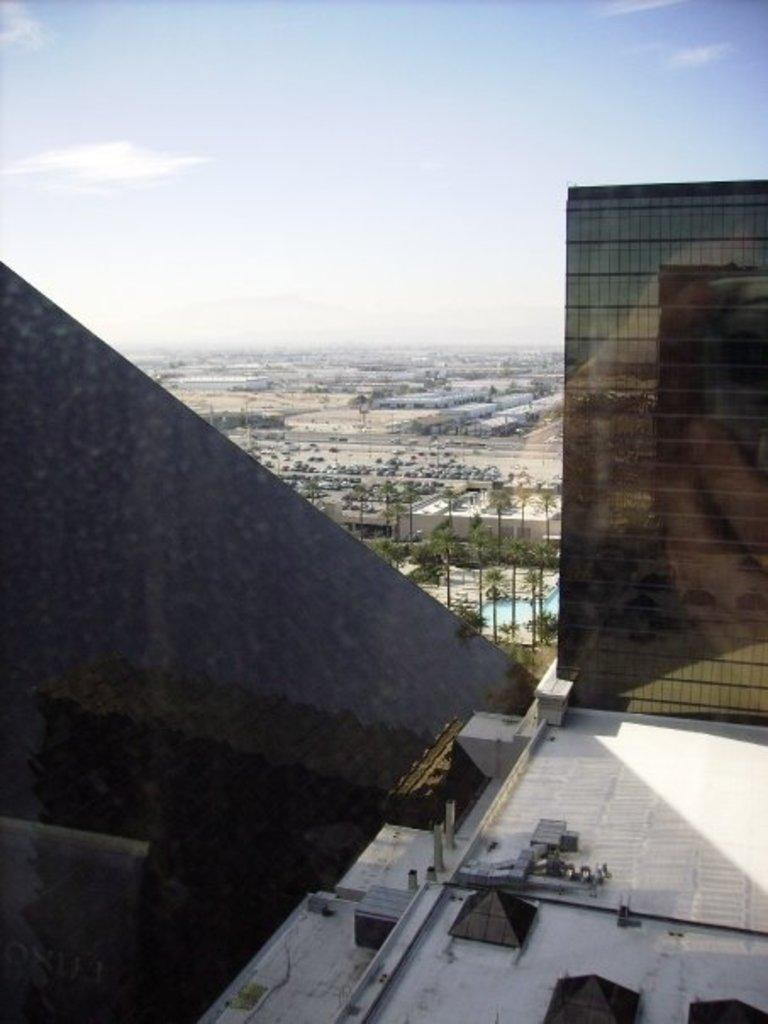What is the main subject of the image? The main subject of the image is the roof of a building. What can be seen in the background of the image? In the background of the image, there are trees, other buildings, and the sky. How many toads can be seen on the roof in the image? There are no toads present in the image; it shows the roof of a building with no visible animals. 